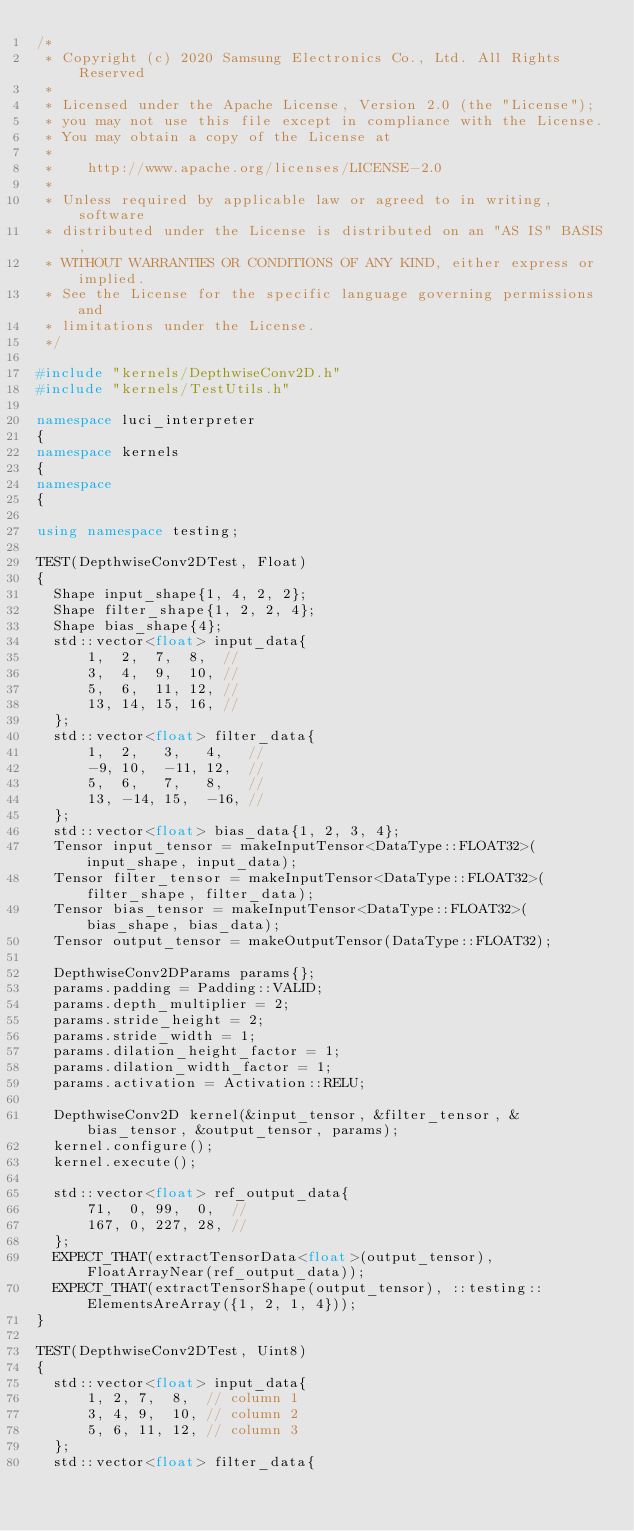<code> <loc_0><loc_0><loc_500><loc_500><_C++_>/*
 * Copyright (c) 2020 Samsung Electronics Co., Ltd. All Rights Reserved
 *
 * Licensed under the Apache License, Version 2.0 (the "License");
 * you may not use this file except in compliance with the License.
 * You may obtain a copy of the License at
 *
 *    http://www.apache.org/licenses/LICENSE-2.0
 *
 * Unless required by applicable law or agreed to in writing, software
 * distributed under the License is distributed on an "AS IS" BASIS,
 * WITHOUT WARRANTIES OR CONDITIONS OF ANY KIND, either express or implied.
 * See the License for the specific language governing permissions and
 * limitations under the License.
 */

#include "kernels/DepthwiseConv2D.h"
#include "kernels/TestUtils.h"

namespace luci_interpreter
{
namespace kernels
{
namespace
{

using namespace testing;

TEST(DepthwiseConv2DTest, Float)
{
  Shape input_shape{1, 4, 2, 2};
  Shape filter_shape{1, 2, 2, 4};
  Shape bias_shape{4};
  std::vector<float> input_data{
      1,  2,  7,  8,  //
      3,  4,  9,  10, //
      5,  6,  11, 12, //
      13, 14, 15, 16, //
  };
  std::vector<float> filter_data{
      1,  2,   3,   4,   //
      -9, 10,  -11, 12,  //
      5,  6,   7,   8,   //
      13, -14, 15,  -16, //
  };
  std::vector<float> bias_data{1, 2, 3, 4};
  Tensor input_tensor = makeInputTensor<DataType::FLOAT32>(input_shape, input_data);
  Tensor filter_tensor = makeInputTensor<DataType::FLOAT32>(filter_shape, filter_data);
  Tensor bias_tensor = makeInputTensor<DataType::FLOAT32>(bias_shape, bias_data);
  Tensor output_tensor = makeOutputTensor(DataType::FLOAT32);

  DepthwiseConv2DParams params{};
  params.padding = Padding::VALID;
  params.depth_multiplier = 2;
  params.stride_height = 2;
  params.stride_width = 1;
  params.dilation_height_factor = 1;
  params.dilation_width_factor = 1;
  params.activation = Activation::RELU;

  DepthwiseConv2D kernel(&input_tensor, &filter_tensor, &bias_tensor, &output_tensor, params);
  kernel.configure();
  kernel.execute();

  std::vector<float> ref_output_data{
      71,  0, 99,  0,  //
      167, 0, 227, 28, //
  };
  EXPECT_THAT(extractTensorData<float>(output_tensor), FloatArrayNear(ref_output_data));
  EXPECT_THAT(extractTensorShape(output_tensor), ::testing::ElementsAreArray({1, 2, 1, 4}));
}

TEST(DepthwiseConv2DTest, Uint8)
{
  std::vector<float> input_data{
      1, 2, 7,  8,  // column 1
      3, 4, 9,  10, // column 2
      5, 6, 11, 12, // column 3
  };
  std::vector<float> filter_data{</code> 